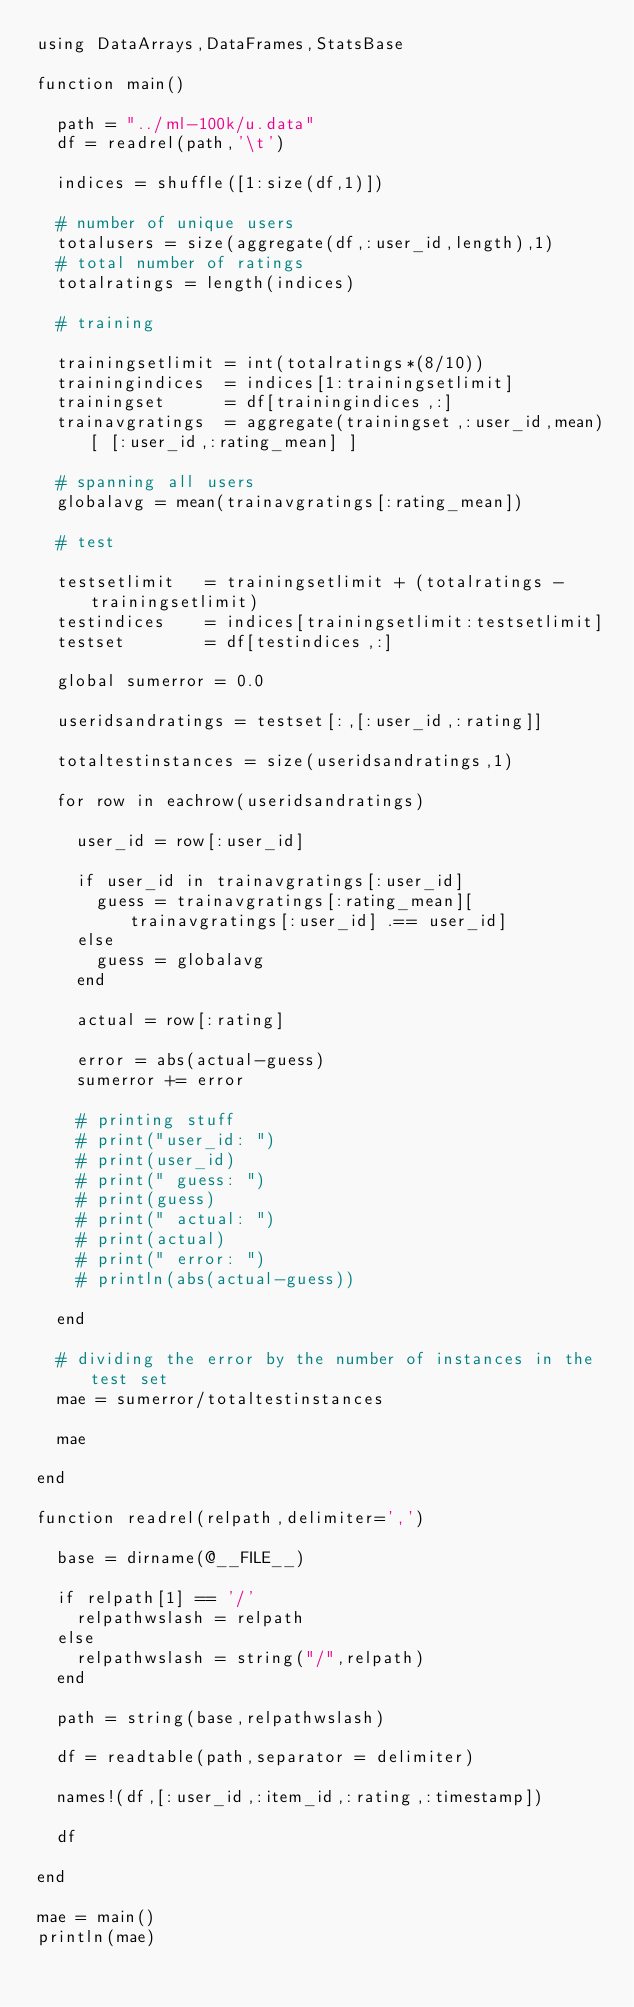<code> <loc_0><loc_0><loc_500><loc_500><_Julia_>using DataArrays,DataFrames,StatsBase

function main()

  path = "../ml-100k/u.data"
  df = readrel(path,'\t')

  indices = shuffle([1:size(df,1)])

  # number of unique users
  totalusers = size(aggregate(df,:user_id,length),1)
  # total number of ratings
  totalratings = length(indices)

  # training

  trainingsetlimit = int(totalratings*(8/10))
  trainingindices  = indices[1:trainingsetlimit]
  trainingset      = df[trainingindices,:]
  trainavgratings  = aggregate(trainingset,:user_id,mean)[ [:user_id,:rating_mean] ]

  # spanning all users
  globalavg = mean(trainavgratings[:rating_mean])

  # test

  testsetlimit   = trainingsetlimit + (totalratings - trainingsetlimit)
  testindices    = indices[trainingsetlimit:testsetlimit]
  testset        = df[testindices,:]

  global sumerror = 0.0

  useridsandratings = testset[:,[:user_id,:rating]]

  totaltestinstances = size(useridsandratings,1)

  for row in eachrow(useridsandratings)

    user_id = row[:user_id]

    if user_id in trainavgratings[:user_id]
      guess = trainavgratings[:rating_mean][trainavgratings[:user_id] .== user_id]
    else
      guess = globalavg
    end

    actual = row[:rating]

    error = abs(actual-guess)
    sumerror += error

    # printing stuff
    # print("user_id: ")
    # print(user_id)
    # print(" guess: ")
    # print(guess)
    # print(" actual: ")
    # print(actual)
    # print(" error: ")
    # println(abs(actual-guess))

  end

  # dividing the error by the number of instances in the test set
  mae = sumerror/totaltestinstances

  mae

end

function readrel(relpath,delimiter=',')

  base = dirname(@__FILE__)

  if relpath[1] == '/'
    relpathwslash = relpath
  else
    relpathwslash = string("/",relpath)
  end

  path = string(base,relpathwslash)

  df = readtable(path,separator = delimiter)

  names!(df,[:user_id,:item_id,:rating,:timestamp])

  df

end

mae = main()
println(mae)
</code> 